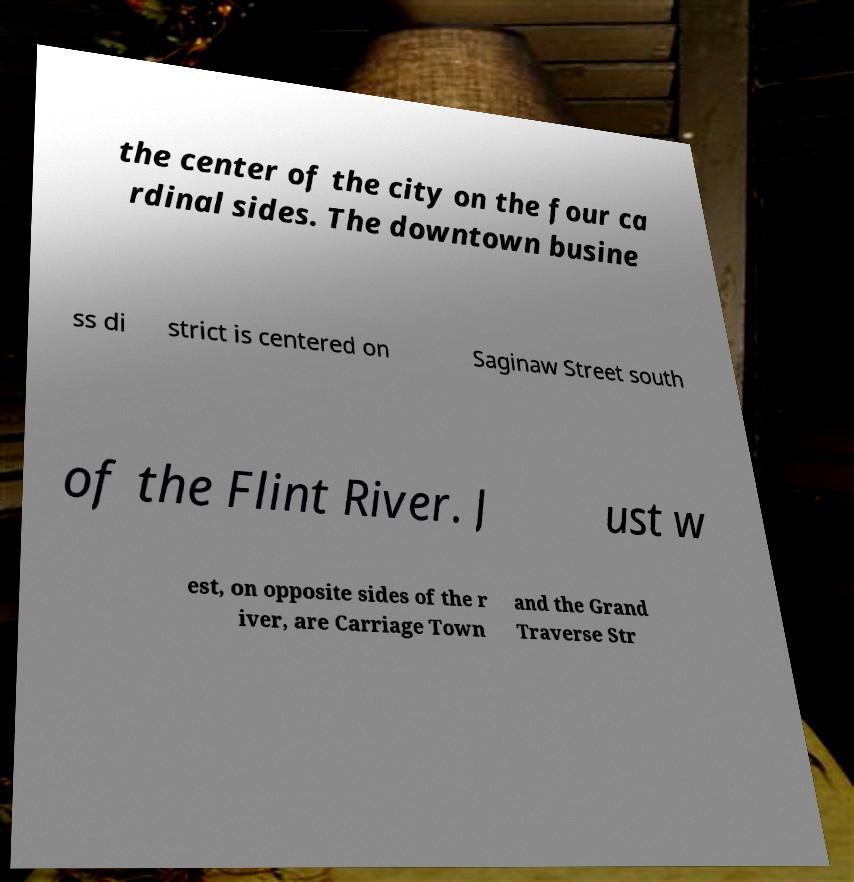Could you extract and type out the text from this image? the center of the city on the four ca rdinal sides. The downtown busine ss di strict is centered on Saginaw Street south of the Flint River. J ust w est, on opposite sides of the r iver, are Carriage Town and the Grand Traverse Str 